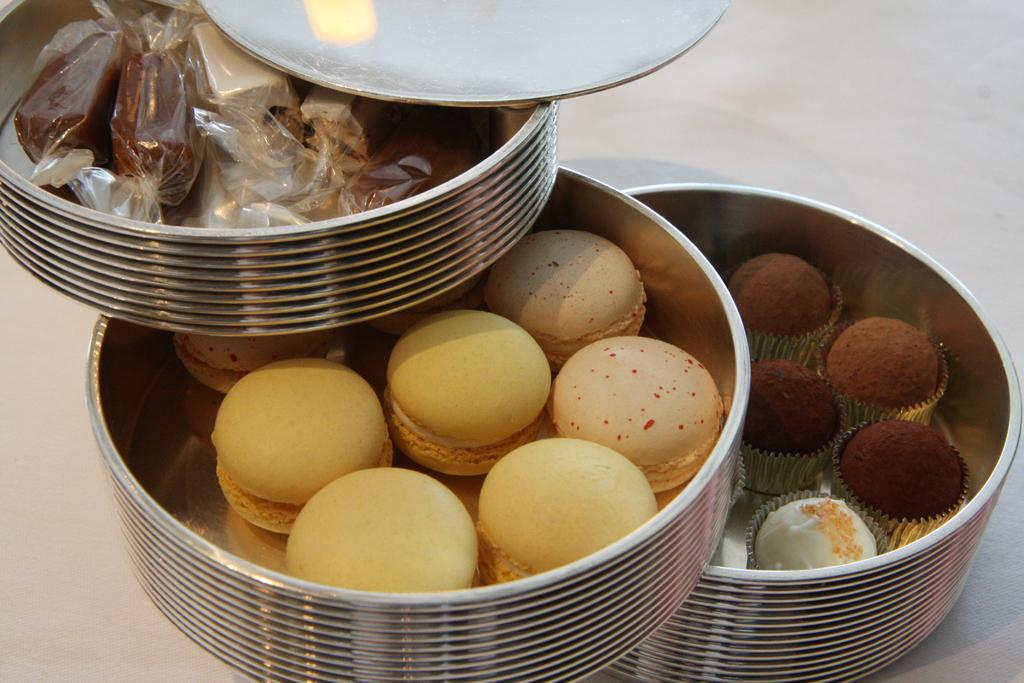What type of baked goods can be seen in the image? There are mini cakes, cookies, and muffins in the image. How are the baked goods stored in the image? The mini cakes, cookies, and muffins are kept in boxes. What disease is being treated with the cookies in the image? There is no mention of a disease or any medical context in the image. The image simply shows mini cakes, cookies, and muffins in boxes. 